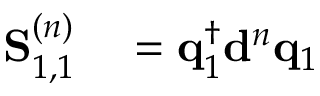<formula> <loc_0><loc_0><loc_500><loc_500>\begin{array} { r l } { S _ { 1 , 1 } ^ { ( n ) } } & = q _ { 1 } ^ { \dagger } d ^ { n } q _ { 1 } } \end{array}</formula> 